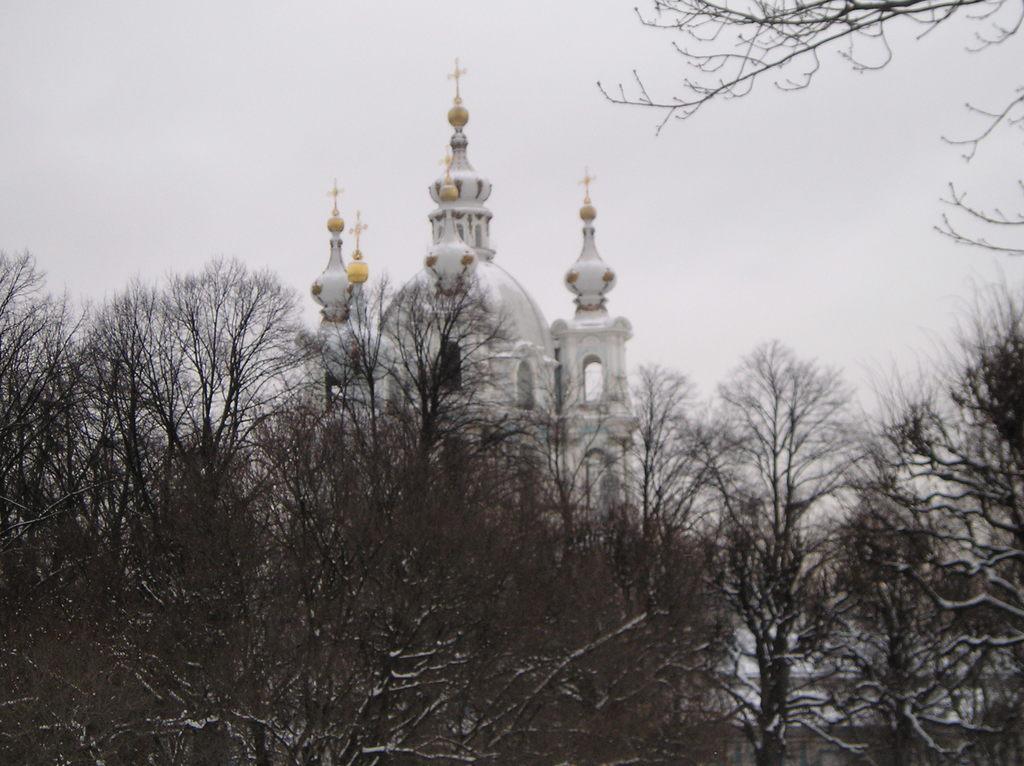In one or two sentences, can you explain what this image depicts? In this image, we can see there are trees. Behind the trees, there is a building and the sky. 